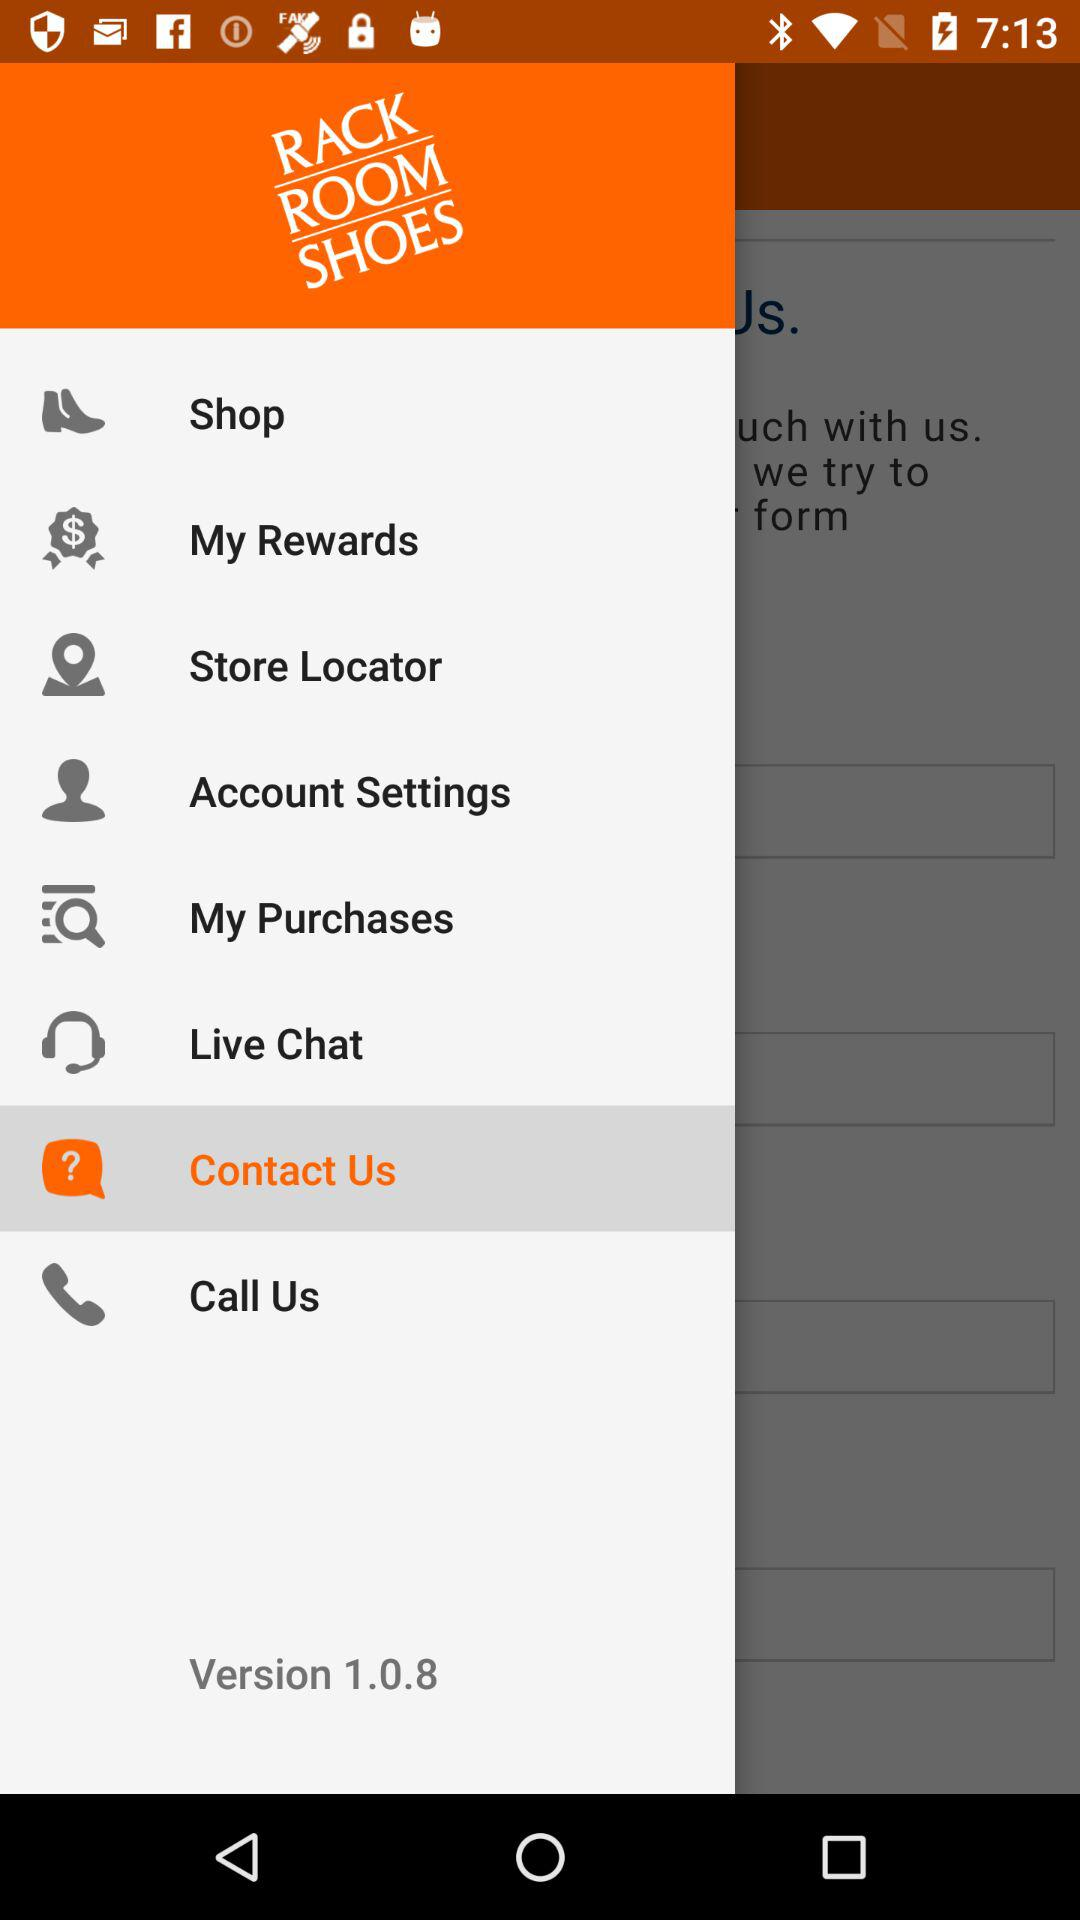What is the version? The version is 1.0.8. 